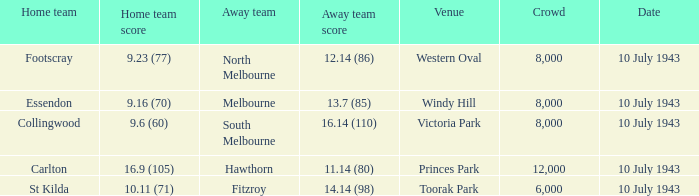At victoria park, what was the score for the team not playing at home? 16.14 (110). 